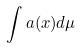<formula> <loc_0><loc_0><loc_500><loc_500>\int a ( x ) d \mu</formula> 